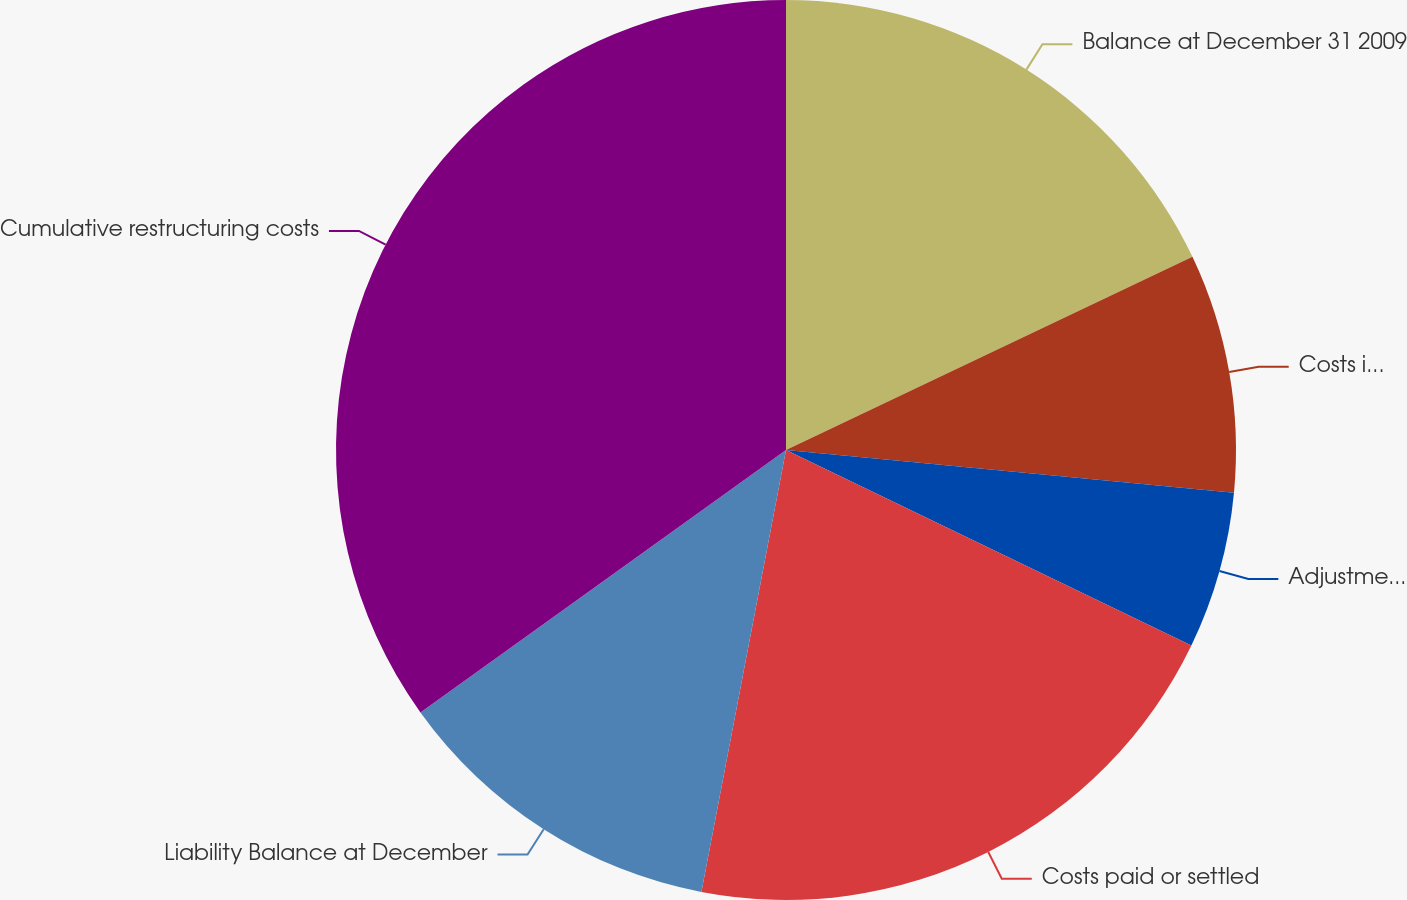<chart> <loc_0><loc_0><loc_500><loc_500><pie_chart><fcel>Balance at December 31 2009<fcel>Costs incurred and charged to<fcel>Adjustments related to the<fcel>Costs paid or settled<fcel>Liability Balance at December<fcel>Cumulative restructuring costs<nl><fcel>17.94%<fcel>8.57%<fcel>5.64%<fcel>20.86%<fcel>12.08%<fcel>34.91%<nl></chart> 